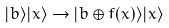Convert formula to latex. <formula><loc_0><loc_0><loc_500><loc_500>| b \rangle | x \rangle \to | b \oplus f ( x ) \rangle | x \rangle</formula> 